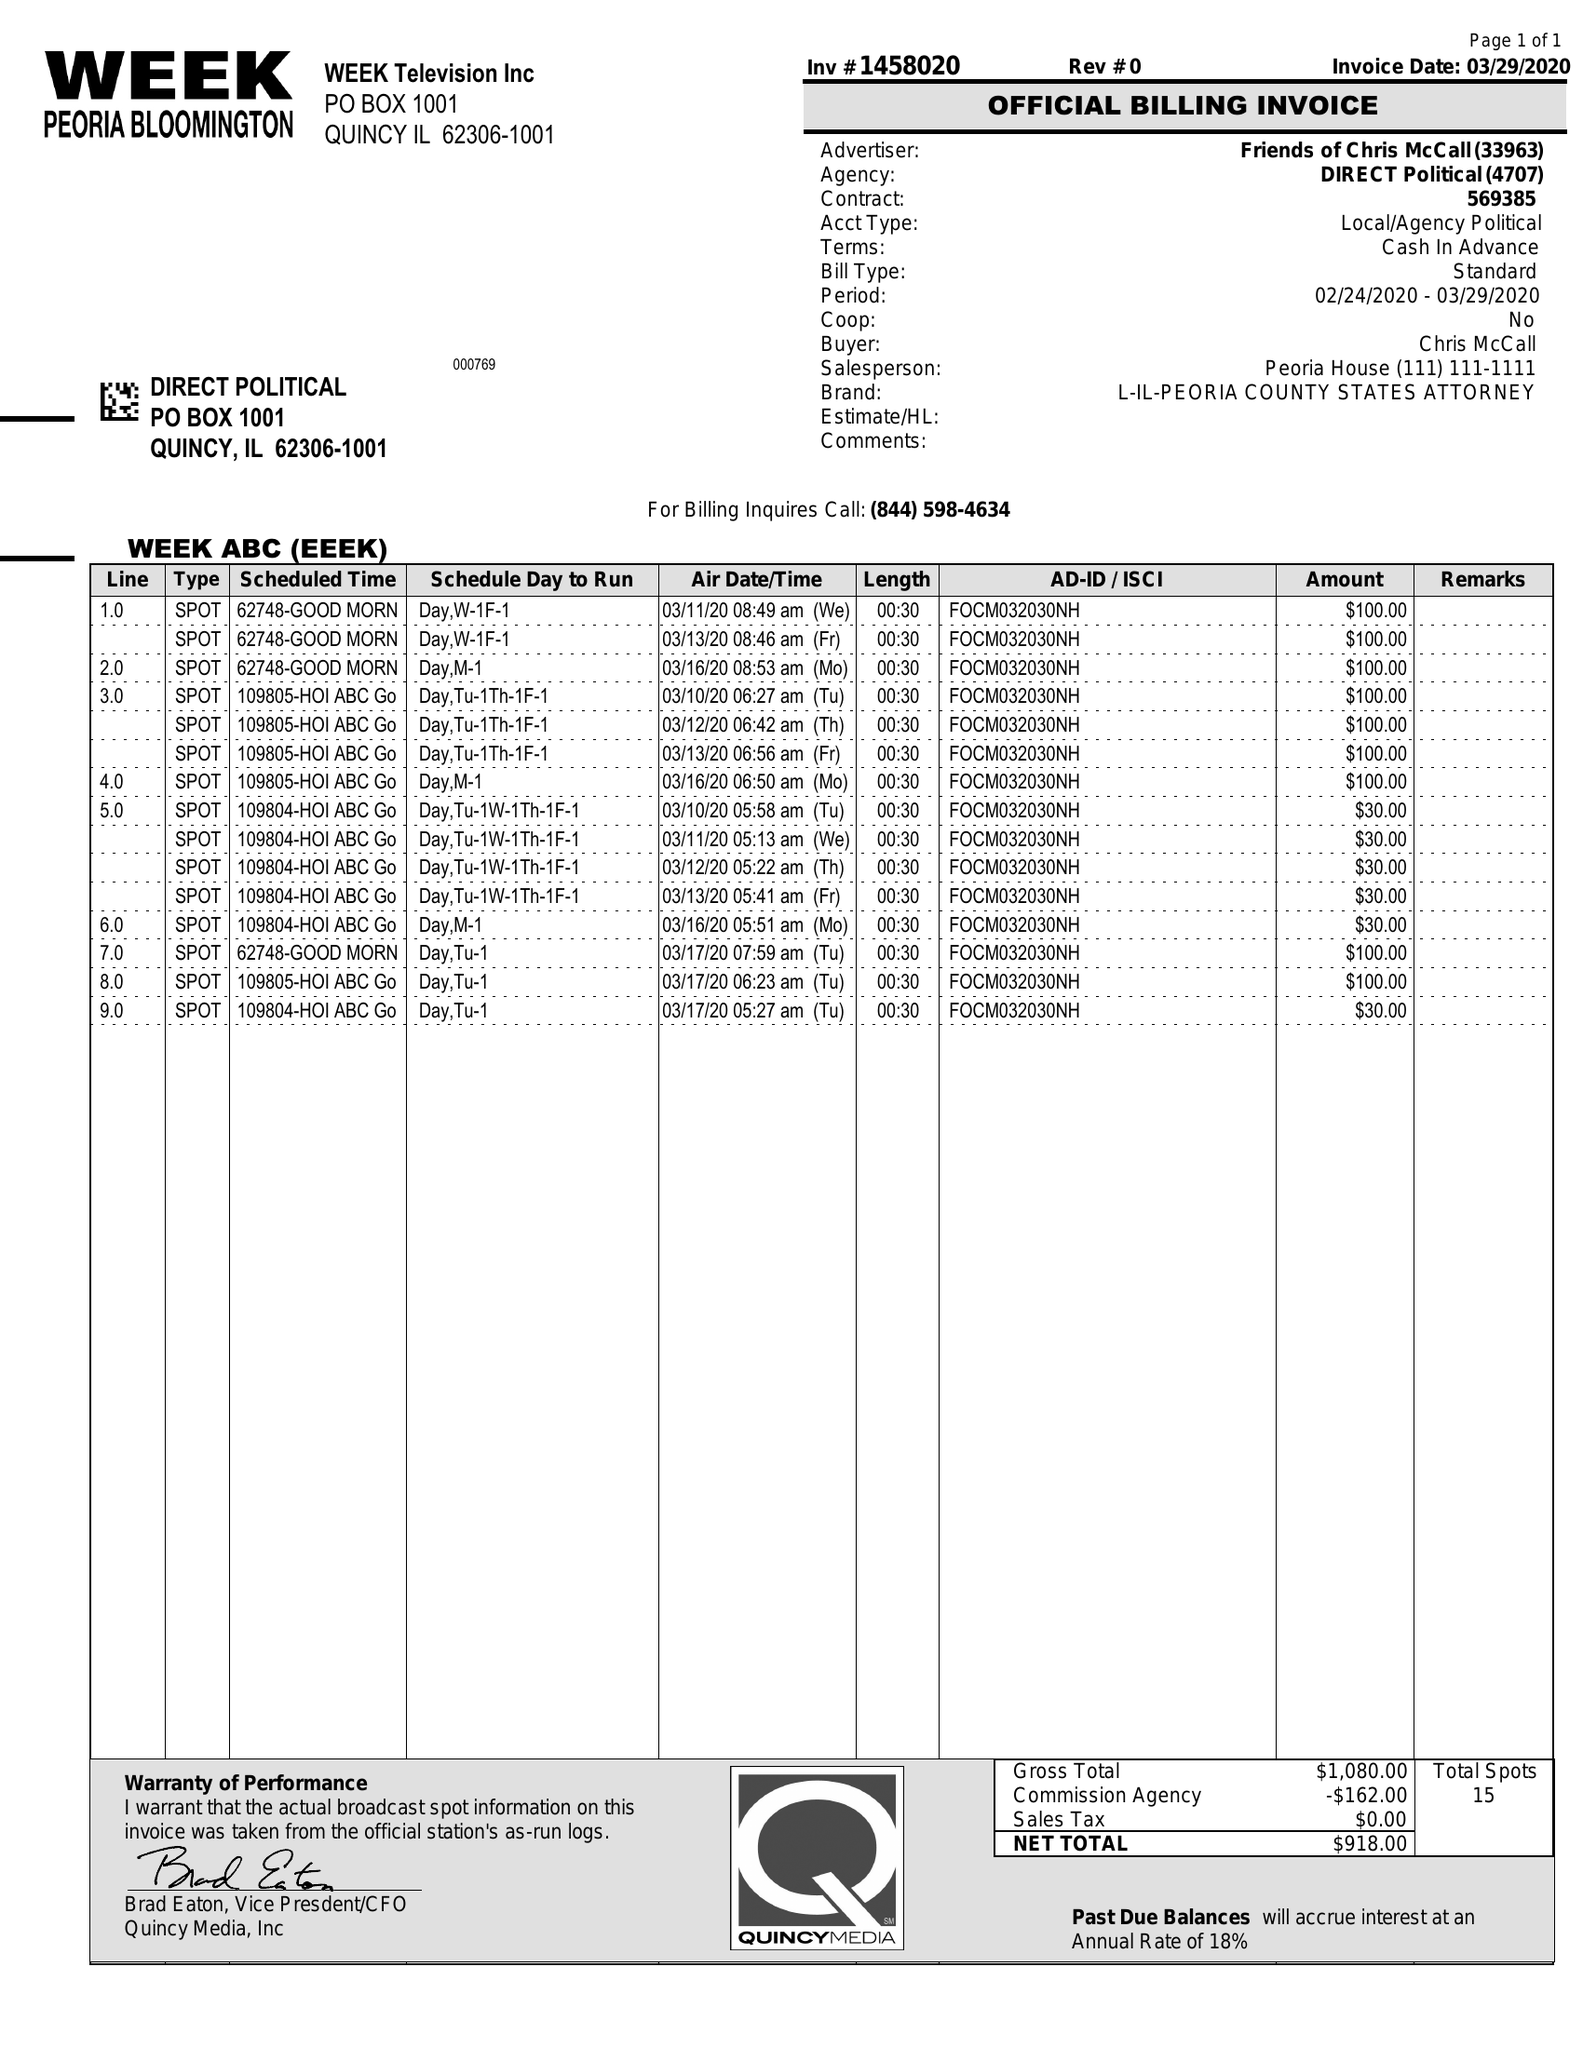What is the value for the gross_amount?
Answer the question using a single word or phrase. 1080.00 